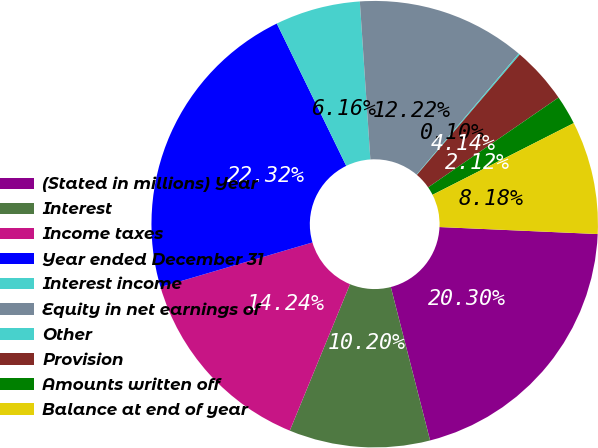<chart> <loc_0><loc_0><loc_500><loc_500><pie_chart><fcel>(Stated in millions) Year<fcel>Interest<fcel>Income taxes<fcel>Year ended December 31<fcel>Interest income<fcel>Equity in net earnings of<fcel>Other<fcel>Provision<fcel>Amounts written off<fcel>Balance at end of year<nl><fcel>20.3%<fcel>10.2%<fcel>14.24%<fcel>22.32%<fcel>6.16%<fcel>12.22%<fcel>0.1%<fcel>4.14%<fcel>2.12%<fcel>8.18%<nl></chart> 